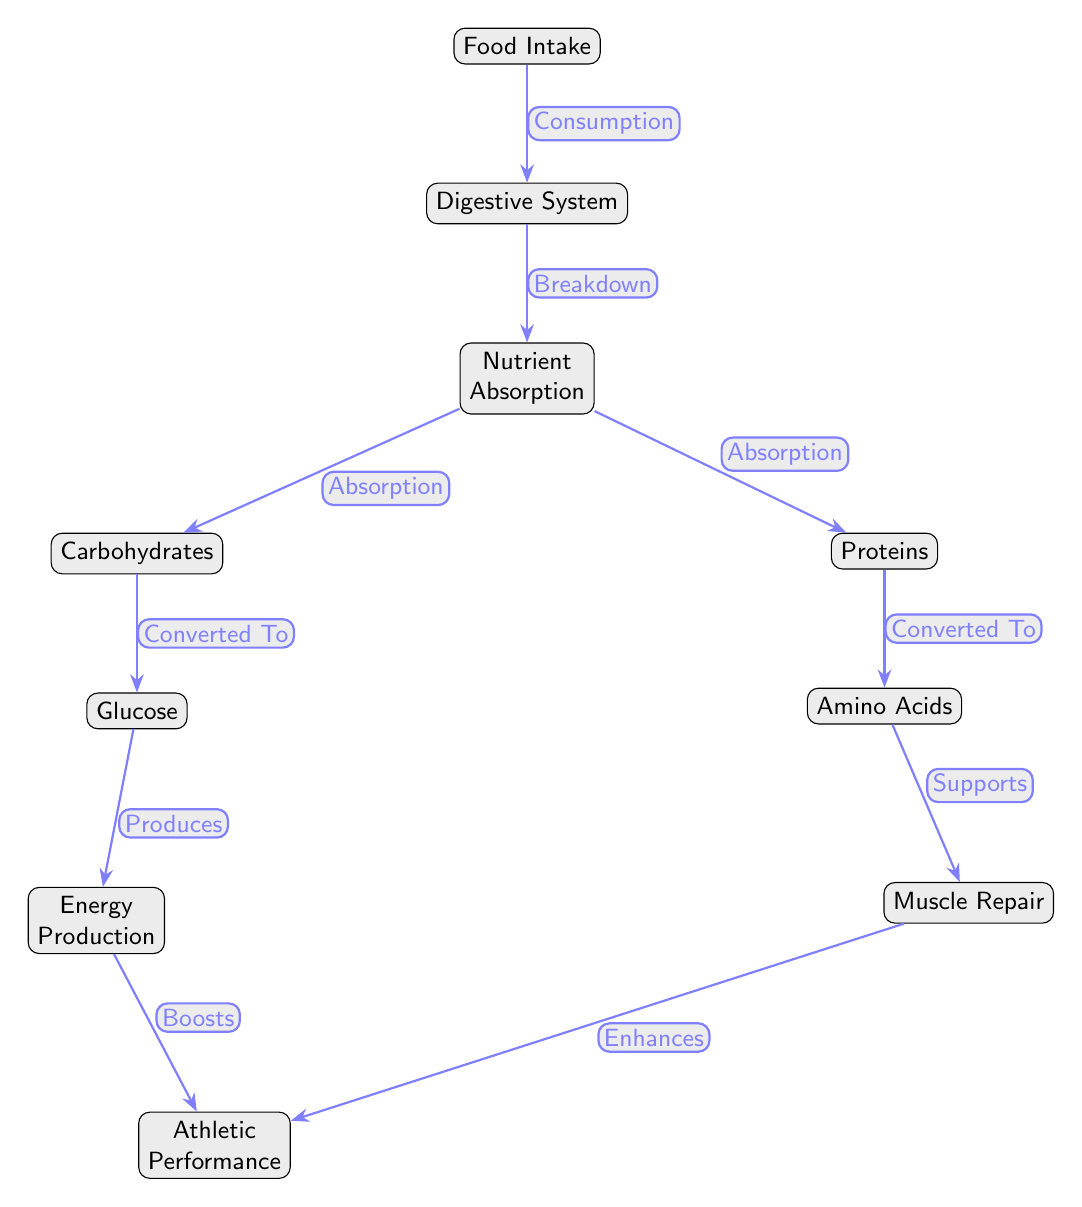What is the first step in the food chain? The diagram shows "Food Intake" as the top node, indicating it is the initial step in the process.
Answer: Food Intake How many nodes are there in total? Counting all nodes in the diagram, we find ten distinct nodes: Food Intake, Digestive System, Nutrient Absorption, Carbohydrates, Proteins, Glucose, Amino Acids, Energy Production, Muscle Repair, and Athletic Performance.
Answer: 10 What are the two types of nutrients absorbed in the nutrient absorption stage? The diagram indicates two distinct nutrients that are absorbed, namely "Carbohydrates" and "Proteins," positioned on either side of the nutrient absorption node.
Answer: Carbohydrates and Proteins What do glucose and amino acids support in the food chain? Both glucose and amino acids lead to different outcomes in the food chain. Glucose leads to "Energy Production," while amino acids lead to "Muscle Repair," both of which contribute to enhancing athletic performance.
Answer: Athletic Performance What is produced from glucose in the food chain? The diagram shows that glucose is converted into "Energy Production," highlighting its role in generating energy from the carbohydrates consumed.
Answer: Energy Production What enhances athletic performance more, energy production or muscle repair? The diagram depicts that both "Energy Production" and "Muscle Repair" enhance "Athletic Performance," but it does not explicitly state which one has a more significant impact; they both contribute.
Answer: Both What process occurs after nutrient absorption? According to the diagram, the process that follows nutrient absorption is "Breakdown," indicating a further step in the food chain where nutrients are processed before absorption.
Answer: Breakdown Which nutrient is specifically converted to glucose? In the diagram, it clearly states that "Carbohydrates" are the nutrient type that is converted to "Glucose," as indicated by the arrow connecting them.
Answer: Carbohydrates What is the relationship between muscle repair and athletic performance? The diagram shows a direct connection labeled "Enhances" from "Muscle Repair" to "Athletic Performance," which signifies that muscle repair contributes positively to athletic performance.
Answer: Enhances 